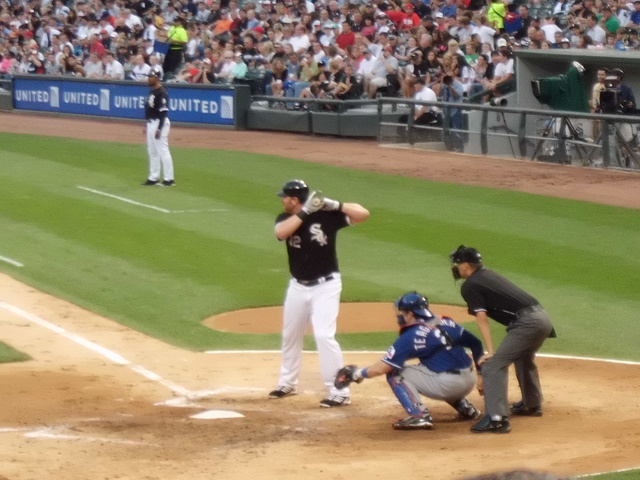Describe the objects in this image and their specific colors. I can see people in gray, darkgray, and black tones, people in gray, lightgray, black, tan, and darkgray tones, people in gray and black tones, people in gray, darkgray, navy, and black tones, and people in gray, lightgray, black, and darkgray tones in this image. 